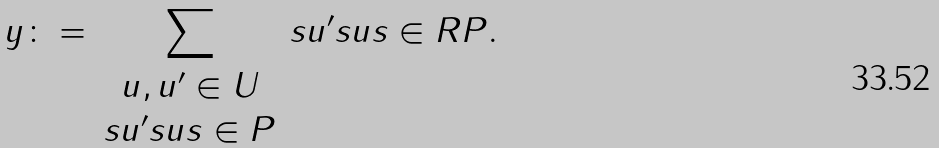Convert formula to latex. <formula><loc_0><loc_0><loc_500><loc_500>y \colon = \sum _ { \begin{array} { c } u , u ^ { \prime } \in U \\ s u ^ { \prime } s u s \in P \end{array} } s u ^ { \prime } s u s \in R P .</formula> 